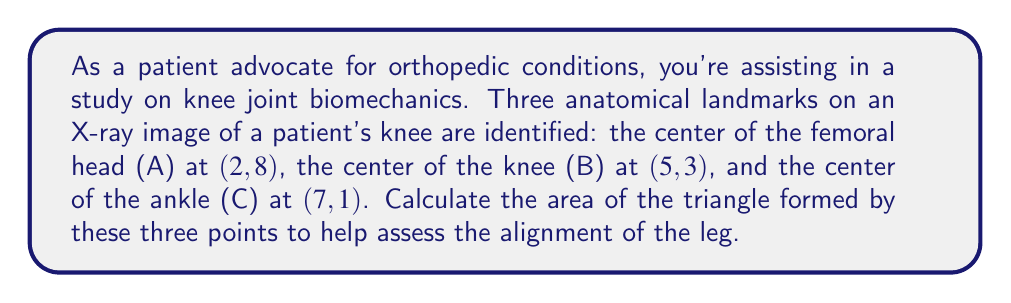Give your solution to this math problem. To calculate the area of a triangle given the coordinates of its vertices, we can use the formula:

$$\text{Area} = \frac{1}{2}|x_1(y_2 - y_3) + x_2(y_3 - y_1) + x_3(y_1 - y_2)|$$

Where $(x_1, y_1)$, $(x_2, y_2)$, and $(x_3, y_3)$ are the coordinates of the three vertices.

Let's assign our points:
A(2, 8), B(5, 3), C(7, 1)

Substituting these into our formula:

$$\begin{align*}
\text{Area} &= \frac{1}{2}|2(3 - 1) + 5(1 - 8) + 7(8 - 3)|\\
&= \frac{1}{2}|2(2) + 5(-7) + 7(5)|\\
&= \frac{1}{2}|4 - 35 + 35|\\
&= \frac{1}{2}|4|\\
&= \frac{1}{2} \cdot 4\\
&= 2
\end{align*}$$

The area is measured in square units of the coordinate system used in the X-ray image.

[asy]
unitsize(20);
pair A = (2,8), B = (5,3), C = (7,1);
draw(A--B--C--cycle, blue);
dot(A); dot(B); dot(C);
label("A (2,8)", A, NE);
label("B (5,3)", B, SE);
label("C (7,1)", C, SE);
draw((-1,0)--(8,0), arrow=Arrow());
draw((0,-1)--(0,9), arrow=Arrow());
label("x", (8,0), E);
label("y", (0,9), N);
[/asy]
Answer: The area of the triangle formed by the three anatomical landmarks is 2 square units. 